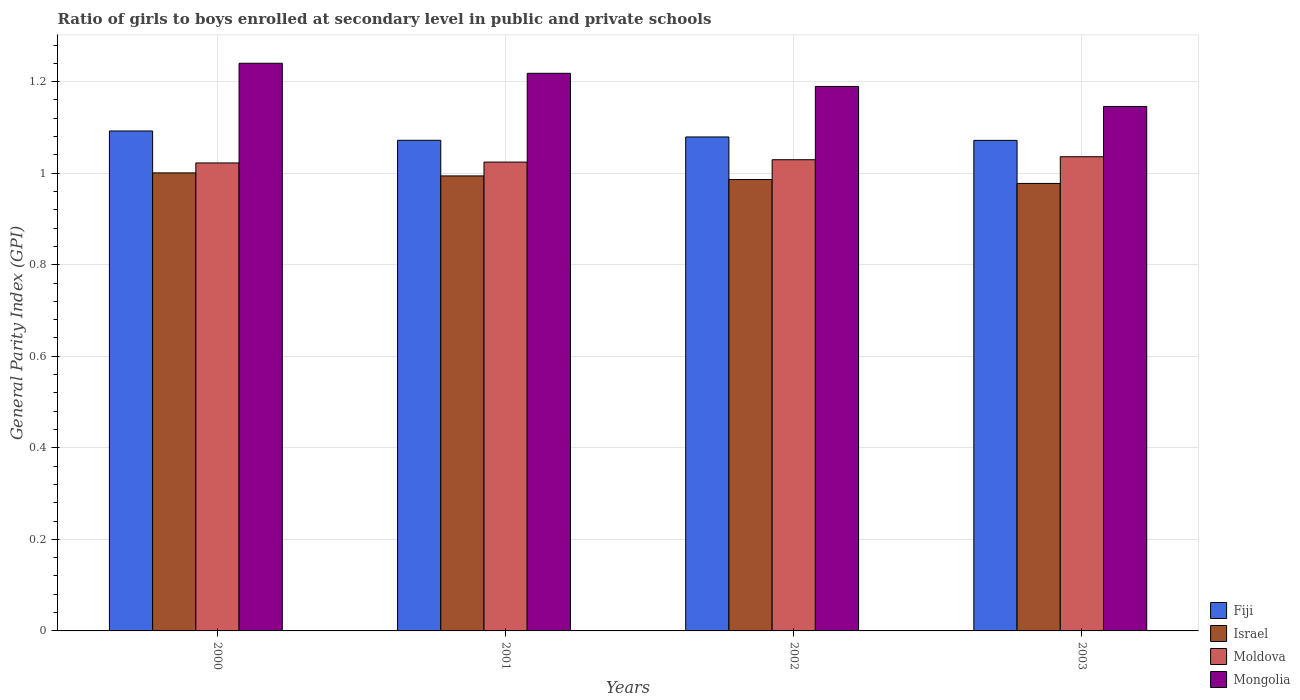How many different coloured bars are there?
Offer a very short reply. 4. Are the number of bars per tick equal to the number of legend labels?
Your response must be concise. Yes. Are the number of bars on each tick of the X-axis equal?
Your answer should be very brief. Yes. How many bars are there on the 4th tick from the right?
Keep it short and to the point. 4. What is the label of the 1st group of bars from the left?
Give a very brief answer. 2000. In how many cases, is the number of bars for a given year not equal to the number of legend labels?
Offer a terse response. 0. What is the general parity index in Moldova in 2002?
Ensure brevity in your answer.  1.03. Across all years, what is the maximum general parity index in Fiji?
Keep it short and to the point. 1.09. Across all years, what is the minimum general parity index in Mongolia?
Make the answer very short. 1.15. In which year was the general parity index in Mongolia maximum?
Provide a short and direct response. 2000. In which year was the general parity index in Moldova minimum?
Give a very brief answer. 2000. What is the total general parity index in Fiji in the graph?
Provide a succinct answer. 4.32. What is the difference between the general parity index in Israel in 2001 and that in 2003?
Offer a terse response. 0.02. What is the difference between the general parity index in Fiji in 2000 and the general parity index in Mongolia in 2001?
Your answer should be compact. -0.13. What is the average general parity index in Moldova per year?
Your answer should be very brief. 1.03. In the year 2003, what is the difference between the general parity index in Moldova and general parity index in Mongolia?
Your response must be concise. -0.11. What is the ratio of the general parity index in Fiji in 2001 to that in 2002?
Give a very brief answer. 0.99. What is the difference between the highest and the second highest general parity index in Mongolia?
Make the answer very short. 0.02. What is the difference between the highest and the lowest general parity index in Israel?
Ensure brevity in your answer.  0.02. In how many years, is the general parity index in Mongolia greater than the average general parity index in Mongolia taken over all years?
Your answer should be compact. 2. Is the sum of the general parity index in Moldova in 2001 and 2002 greater than the maximum general parity index in Fiji across all years?
Ensure brevity in your answer.  Yes. Is it the case that in every year, the sum of the general parity index in Moldova and general parity index in Fiji is greater than the sum of general parity index in Israel and general parity index in Mongolia?
Provide a succinct answer. No. What does the 4th bar from the left in 2001 represents?
Your response must be concise. Mongolia. What does the 2nd bar from the right in 2002 represents?
Your answer should be very brief. Moldova. Is it the case that in every year, the sum of the general parity index in Fiji and general parity index in Israel is greater than the general parity index in Moldova?
Your answer should be very brief. Yes. Are all the bars in the graph horizontal?
Offer a very short reply. No. What is the difference between two consecutive major ticks on the Y-axis?
Offer a terse response. 0.2. Are the values on the major ticks of Y-axis written in scientific E-notation?
Provide a short and direct response. No. Does the graph contain any zero values?
Offer a very short reply. No. How many legend labels are there?
Offer a very short reply. 4. What is the title of the graph?
Your answer should be very brief. Ratio of girls to boys enrolled at secondary level in public and private schools. Does "Slovenia" appear as one of the legend labels in the graph?
Ensure brevity in your answer.  No. What is the label or title of the Y-axis?
Offer a terse response. General Parity Index (GPI). What is the General Parity Index (GPI) in Fiji in 2000?
Give a very brief answer. 1.09. What is the General Parity Index (GPI) of Israel in 2000?
Provide a succinct answer. 1. What is the General Parity Index (GPI) of Moldova in 2000?
Your answer should be compact. 1.02. What is the General Parity Index (GPI) in Mongolia in 2000?
Keep it short and to the point. 1.24. What is the General Parity Index (GPI) of Fiji in 2001?
Make the answer very short. 1.07. What is the General Parity Index (GPI) of Israel in 2001?
Provide a succinct answer. 0.99. What is the General Parity Index (GPI) of Moldova in 2001?
Provide a short and direct response. 1.02. What is the General Parity Index (GPI) in Mongolia in 2001?
Your answer should be compact. 1.22. What is the General Parity Index (GPI) in Fiji in 2002?
Provide a short and direct response. 1.08. What is the General Parity Index (GPI) in Israel in 2002?
Give a very brief answer. 0.99. What is the General Parity Index (GPI) in Moldova in 2002?
Make the answer very short. 1.03. What is the General Parity Index (GPI) of Mongolia in 2002?
Your response must be concise. 1.19. What is the General Parity Index (GPI) in Fiji in 2003?
Make the answer very short. 1.07. What is the General Parity Index (GPI) in Israel in 2003?
Provide a short and direct response. 0.98. What is the General Parity Index (GPI) in Moldova in 2003?
Provide a succinct answer. 1.04. What is the General Parity Index (GPI) in Mongolia in 2003?
Provide a succinct answer. 1.15. Across all years, what is the maximum General Parity Index (GPI) of Fiji?
Provide a short and direct response. 1.09. Across all years, what is the maximum General Parity Index (GPI) of Israel?
Offer a very short reply. 1. Across all years, what is the maximum General Parity Index (GPI) in Moldova?
Your response must be concise. 1.04. Across all years, what is the maximum General Parity Index (GPI) in Mongolia?
Give a very brief answer. 1.24. Across all years, what is the minimum General Parity Index (GPI) of Fiji?
Offer a terse response. 1.07. Across all years, what is the minimum General Parity Index (GPI) in Israel?
Your answer should be very brief. 0.98. Across all years, what is the minimum General Parity Index (GPI) of Moldova?
Ensure brevity in your answer.  1.02. Across all years, what is the minimum General Parity Index (GPI) in Mongolia?
Provide a short and direct response. 1.15. What is the total General Parity Index (GPI) in Fiji in the graph?
Offer a very short reply. 4.32. What is the total General Parity Index (GPI) of Israel in the graph?
Your answer should be very brief. 3.96. What is the total General Parity Index (GPI) of Moldova in the graph?
Give a very brief answer. 4.11. What is the total General Parity Index (GPI) of Mongolia in the graph?
Provide a short and direct response. 4.79. What is the difference between the General Parity Index (GPI) of Fiji in 2000 and that in 2001?
Make the answer very short. 0.02. What is the difference between the General Parity Index (GPI) of Israel in 2000 and that in 2001?
Your answer should be compact. 0.01. What is the difference between the General Parity Index (GPI) in Moldova in 2000 and that in 2001?
Your answer should be very brief. -0. What is the difference between the General Parity Index (GPI) of Mongolia in 2000 and that in 2001?
Keep it short and to the point. 0.02. What is the difference between the General Parity Index (GPI) of Fiji in 2000 and that in 2002?
Give a very brief answer. 0.01. What is the difference between the General Parity Index (GPI) of Israel in 2000 and that in 2002?
Offer a very short reply. 0.01. What is the difference between the General Parity Index (GPI) of Moldova in 2000 and that in 2002?
Your answer should be compact. -0.01. What is the difference between the General Parity Index (GPI) in Mongolia in 2000 and that in 2002?
Your answer should be compact. 0.05. What is the difference between the General Parity Index (GPI) of Fiji in 2000 and that in 2003?
Give a very brief answer. 0.02. What is the difference between the General Parity Index (GPI) of Israel in 2000 and that in 2003?
Offer a terse response. 0.02. What is the difference between the General Parity Index (GPI) of Moldova in 2000 and that in 2003?
Ensure brevity in your answer.  -0.01. What is the difference between the General Parity Index (GPI) of Mongolia in 2000 and that in 2003?
Your answer should be very brief. 0.09. What is the difference between the General Parity Index (GPI) in Fiji in 2001 and that in 2002?
Ensure brevity in your answer.  -0.01. What is the difference between the General Parity Index (GPI) of Israel in 2001 and that in 2002?
Offer a very short reply. 0.01. What is the difference between the General Parity Index (GPI) in Moldova in 2001 and that in 2002?
Your response must be concise. -0.01. What is the difference between the General Parity Index (GPI) in Mongolia in 2001 and that in 2002?
Your answer should be very brief. 0.03. What is the difference between the General Parity Index (GPI) in Fiji in 2001 and that in 2003?
Ensure brevity in your answer.  0. What is the difference between the General Parity Index (GPI) in Israel in 2001 and that in 2003?
Your answer should be compact. 0.02. What is the difference between the General Parity Index (GPI) of Moldova in 2001 and that in 2003?
Ensure brevity in your answer.  -0.01. What is the difference between the General Parity Index (GPI) in Mongolia in 2001 and that in 2003?
Provide a succinct answer. 0.07. What is the difference between the General Parity Index (GPI) of Fiji in 2002 and that in 2003?
Provide a short and direct response. 0.01. What is the difference between the General Parity Index (GPI) in Israel in 2002 and that in 2003?
Provide a short and direct response. 0.01. What is the difference between the General Parity Index (GPI) in Moldova in 2002 and that in 2003?
Offer a very short reply. -0.01. What is the difference between the General Parity Index (GPI) in Mongolia in 2002 and that in 2003?
Make the answer very short. 0.04. What is the difference between the General Parity Index (GPI) in Fiji in 2000 and the General Parity Index (GPI) in Israel in 2001?
Offer a very short reply. 0.1. What is the difference between the General Parity Index (GPI) in Fiji in 2000 and the General Parity Index (GPI) in Moldova in 2001?
Offer a very short reply. 0.07. What is the difference between the General Parity Index (GPI) in Fiji in 2000 and the General Parity Index (GPI) in Mongolia in 2001?
Your response must be concise. -0.13. What is the difference between the General Parity Index (GPI) in Israel in 2000 and the General Parity Index (GPI) in Moldova in 2001?
Your answer should be very brief. -0.02. What is the difference between the General Parity Index (GPI) in Israel in 2000 and the General Parity Index (GPI) in Mongolia in 2001?
Offer a terse response. -0.22. What is the difference between the General Parity Index (GPI) of Moldova in 2000 and the General Parity Index (GPI) of Mongolia in 2001?
Provide a short and direct response. -0.2. What is the difference between the General Parity Index (GPI) in Fiji in 2000 and the General Parity Index (GPI) in Israel in 2002?
Offer a very short reply. 0.11. What is the difference between the General Parity Index (GPI) of Fiji in 2000 and the General Parity Index (GPI) of Moldova in 2002?
Offer a terse response. 0.06. What is the difference between the General Parity Index (GPI) in Fiji in 2000 and the General Parity Index (GPI) in Mongolia in 2002?
Give a very brief answer. -0.1. What is the difference between the General Parity Index (GPI) in Israel in 2000 and the General Parity Index (GPI) in Moldova in 2002?
Provide a short and direct response. -0.03. What is the difference between the General Parity Index (GPI) in Israel in 2000 and the General Parity Index (GPI) in Mongolia in 2002?
Your response must be concise. -0.19. What is the difference between the General Parity Index (GPI) of Moldova in 2000 and the General Parity Index (GPI) of Mongolia in 2002?
Offer a terse response. -0.17. What is the difference between the General Parity Index (GPI) of Fiji in 2000 and the General Parity Index (GPI) of Israel in 2003?
Your answer should be very brief. 0.11. What is the difference between the General Parity Index (GPI) of Fiji in 2000 and the General Parity Index (GPI) of Moldova in 2003?
Offer a very short reply. 0.06. What is the difference between the General Parity Index (GPI) of Fiji in 2000 and the General Parity Index (GPI) of Mongolia in 2003?
Give a very brief answer. -0.05. What is the difference between the General Parity Index (GPI) of Israel in 2000 and the General Parity Index (GPI) of Moldova in 2003?
Provide a short and direct response. -0.04. What is the difference between the General Parity Index (GPI) in Israel in 2000 and the General Parity Index (GPI) in Mongolia in 2003?
Give a very brief answer. -0.15. What is the difference between the General Parity Index (GPI) in Moldova in 2000 and the General Parity Index (GPI) in Mongolia in 2003?
Your answer should be very brief. -0.12. What is the difference between the General Parity Index (GPI) in Fiji in 2001 and the General Parity Index (GPI) in Israel in 2002?
Your answer should be compact. 0.09. What is the difference between the General Parity Index (GPI) in Fiji in 2001 and the General Parity Index (GPI) in Moldova in 2002?
Your answer should be very brief. 0.04. What is the difference between the General Parity Index (GPI) in Fiji in 2001 and the General Parity Index (GPI) in Mongolia in 2002?
Provide a short and direct response. -0.12. What is the difference between the General Parity Index (GPI) of Israel in 2001 and the General Parity Index (GPI) of Moldova in 2002?
Offer a terse response. -0.04. What is the difference between the General Parity Index (GPI) of Israel in 2001 and the General Parity Index (GPI) of Mongolia in 2002?
Offer a terse response. -0.2. What is the difference between the General Parity Index (GPI) in Moldova in 2001 and the General Parity Index (GPI) in Mongolia in 2002?
Your answer should be compact. -0.17. What is the difference between the General Parity Index (GPI) in Fiji in 2001 and the General Parity Index (GPI) in Israel in 2003?
Your response must be concise. 0.09. What is the difference between the General Parity Index (GPI) of Fiji in 2001 and the General Parity Index (GPI) of Moldova in 2003?
Provide a succinct answer. 0.04. What is the difference between the General Parity Index (GPI) in Fiji in 2001 and the General Parity Index (GPI) in Mongolia in 2003?
Make the answer very short. -0.07. What is the difference between the General Parity Index (GPI) in Israel in 2001 and the General Parity Index (GPI) in Moldova in 2003?
Offer a terse response. -0.04. What is the difference between the General Parity Index (GPI) of Israel in 2001 and the General Parity Index (GPI) of Mongolia in 2003?
Provide a short and direct response. -0.15. What is the difference between the General Parity Index (GPI) in Moldova in 2001 and the General Parity Index (GPI) in Mongolia in 2003?
Give a very brief answer. -0.12. What is the difference between the General Parity Index (GPI) of Fiji in 2002 and the General Parity Index (GPI) of Israel in 2003?
Make the answer very short. 0.1. What is the difference between the General Parity Index (GPI) of Fiji in 2002 and the General Parity Index (GPI) of Moldova in 2003?
Give a very brief answer. 0.04. What is the difference between the General Parity Index (GPI) of Fiji in 2002 and the General Parity Index (GPI) of Mongolia in 2003?
Your response must be concise. -0.07. What is the difference between the General Parity Index (GPI) in Israel in 2002 and the General Parity Index (GPI) in Moldova in 2003?
Keep it short and to the point. -0.05. What is the difference between the General Parity Index (GPI) in Israel in 2002 and the General Parity Index (GPI) in Mongolia in 2003?
Provide a short and direct response. -0.16. What is the difference between the General Parity Index (GPI) in Moldova in 2002 and the General Parity Index (GPI) in Mongolia in 2003?
Make the answer very short. -0.12. What is the average General Parity Index (GPI) of Fiji per year?
Give a very brief answer. 1.08. What is the average General Parity Index (GPI) in Israel per year?
Offer a terse response. 0.99. What is the average General Parity Index (GPI) of Moldova per year?
Your response must be concise. 1.03. What is the average General Parity Index (GPI) of Mongolia per year?
Keep it short and to the point. 1.2. In the year 2000, what is the difference between the General Parity Index (GPI) in Fiji and General Parity Index (GPI) in Israel?
Provide a short and direct response. 0.09. In the year 2000, what is the difference between the General Parity Index (GPI) of Fiji and General Parity Index (GPI) of Moldova?
Ensure brevity in your answer.  0.07. In the year 2000, what is the difference between the General Parity Index (GPI) in Fiji and General Parity Index (GPI) in Mongolia?
Your answer should be very brief. -0.15. In the year 2000, what is the difference between the General Parity Index (GPI) in Israel and General Parity Index (GPI) in Moldova?
Your answer should be compact. -0.02. In the year 2000, what is the difference between the General Parity Index (GPI) in Israel and General Parity Index (GPI) in Mongolia?
Provide a short and direct response. -0.24. In the year 2000, what is the difference between the General Parity Index (GPI) of Moldova and General Parity Index (GPI) of Mongolia?
Your answer should be compact. -0.22. In the year 2001, what is the difference between the General Parity Index (GPI) of Fiji and General Parity Index (GPI) of Israel?
Make the answer very short. 0.08. In the year 2001, what is the difference between the General Parity Index (GPI) in Fiji and General Parity Index (GPI) in Moldova?
Provide a succinct answer. 0.05. In the year 2001, what is the difference between the General Parity Index (GPI) of Fiji and General Parity Index (GPI) of Mongolia?
Your answer should be very brief. -0.15. In the year 2001, what is the difference between the General Parity Index (GPI) of Israel and General Parity Index (GPI) of Moldova?
Your answer should be compact. -0.03. In the year 2001, what is the difference between the General Parity Index (GPI) of Israel and General Parity Index (GPI) of Mongolia?
Give a very brief answer. -0.22. In the year 2001, what is the difference between the General Parity Index (GPI) of Moldova and General Parity Index (GPI) of Mongolia?
Provide a short and direct response. -0.19. In the year 2002, what is the difference between the General Parity Index (GPI) in Fiji and General Parity Index (GPI) in Israel?
Your response must be concise. 0.09. In the year 2002, what is the difference between the General Parity Index (GPI) of Fiji and General Parity Index (GPI) of Moldova?
Your answer should be compact. 0.05. In the year 2002, what is the difference between the General Parity Index (GPI) in Fiji and General Parity Index (GPI) in Mongolia?
Give a very brief answer. -0.11. In the year 2002, what is the difference between the General Parity Index (GPI) in Israel and General Parity Index (GPI) in Moldova?
Make the answer very short. -0.04. In the year 2002, what is the difference between the General Parity Index (GPI) of Israel and General Parity Index (GPI) of Mongolia?
Provide a succinct answer. -0.2. In the year 2002, what is the difference between the General Parity Index (GPI) of Moldova and General Parity Index (GPI) of Mongolia?
Keep it short and to the point. -0.16. In the year 2003, what is the difference between the General Parity Index (GPI) of Fiji and General Parity Index (GPI) of Israel?
Offer a very short reply. 0.09. In the year 2003, what is the difference between the General Parity Index (GPI) in Fiji and General Parity Index (GPI) in Moldova?
Your answer should be very brief. 0.04. In the year 2003, what is the difference between the General Parity Index (GPI) of Fiji and General Parity Index (GPI) of Mongolia?
Provide a succinct answer. -0.07. In the year 2003, what is the difference between the General Parity Index (GPI) in Israel and General Parity Index (GPI) in Moldova?
Give a very brief answer. -0.06. In the year 2003, what is the difference between the General Parity Index (GPI) in Israel and General Parity Index (GPI) in Mongolia?
Provide a succinct answer. -0.17. In the year 2003, what is the difference between the General Parity Index (GPI) in Moldova and General Parity Index (GPI) in Mongolia?
Offer a very short reply. -0.11. What is the ratio of the General Parity Index (GPI) in Israel in 2000 to that in 2001?
Provide a short and direct response. 1.01. What is the ratio of the General Parity Index (GPI) of Mongolia in 2000 to that in 2001?
Offer a very short reply. 1.02. What is the ratio of the General Parity Index (GPI) of Fiji in 2000 to that in 2002?
Give a very brief answer. 1.01. What is the ratio of the General Parity Index (GPI) of Israel in 2000 to that in 2002?
Ensure brevity in your answer.  1.01. What is the ratio of the General Parity Index (GPI) in Mongolia in 2000 to that in 2002?
Keep it short and to the point. 1.04. What is the ratio of the General Parity Index (GPI) in Fiji in 2000 to that in 2003?
Offer a terse response. 1.02. What is the ratio of the General Parity Index (GPI) of Israel in 2000 to that in 2003?
Offer a terse response. 1.02. What is the ratio of the General Parity Index (GPI) of Moldova in 2000 to that in 2003?
Your answer should be compact. 0.99. What is the ratio of the General Parity Index (GPI) in Mongolia in 2000 to that in 2003?
Give a very brief answer. 1.08. What is the ratio of the General Parity Index (GPI) in Israel in 2001 to that in 2002?
Provide a short and direct response. 1.01. What is the ratio of the General Parity Index (GPI) of Moldova in 2001 to that in 2002?
Offer a very short reply. 0.99. What is the ratio of the General Parity Index (GPI) of Mongolia in 2001 to that in 2002?
Ensure brevity in your answer.  1.02. What is the ratio of the General Parity Index (GPI) of Fiji in 2001 to that in 2003?
Offer a terse response. 1. What is the ratio of the General Parity Index (GPI) of Israel in 2001 to that in 2003?
Offer a very short reply. 1.02. What is the ratio of the General Parity Index (GPI) of Mongolia in 2001 to that in 2003?
Your answer should be very brief. 1.06. What is the ratio of the General Parity Index (GPI) of Israel in 2002 to that in 2003?
Your answer should be very brief. 1.01. What is the ratio of the General Parity Index (GPI) of Mongolia in 2002 to that in 2003?
Offer a very short reply. 1.04. What is the difference between the highest and the second highest General Parity Index (GPI) in Fiji?
Provide a succinct answer. 0.01. What is the difference between the highest and the second highest General Parity Index (GPI) in Israel?
Make the answer very short. 0.01. What is the difference between the highest and the second highest General Parity Index (GPI) of Moldova?
Your answer should be very brief. 0.01. What is the difference between the highest and the second highest General Parity Index (GPI) in Mongolia?
Your answer should be very brief. 0.02. What is the difference between the highest and the lowest General Parity Index (GPI) in Fiji?
Offer a terse response. 0.02. What is the difference between the highest and the lowest General Parity Index (GPI) of Israel?
Give a very brief answer. 0.02. What is the difference between the highest and the lowest General Parity Index (GPI) in Moldova?
Your response must be concise. 0.01. What is the difference between the highest and the lowest General Parity Index (GPI) in Mongolia?
Your response must be concise. 0.09. 